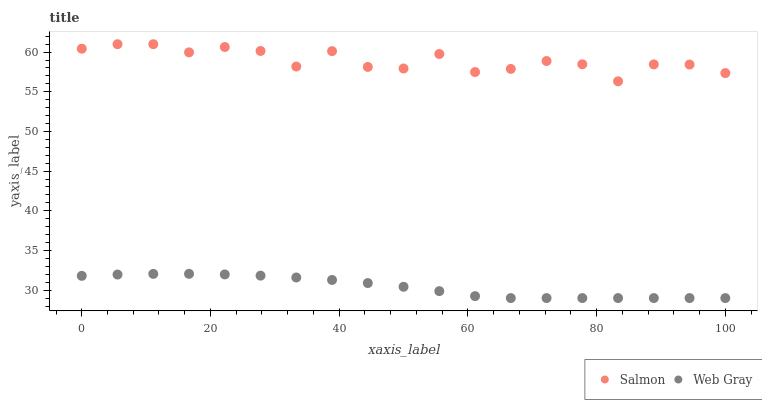Does Web Gray have the minimum area under the curve?
Answer yes or no. Yes. Does Salmon have the maximum area under the curve?
Answer yes or no. Yes. Does Salmon have the minimum area under the curve?
Answer yes or no. No. Is Web Gray the smoothest?
Answer yes or no. Yes. Is Salmon the roughest?
Answer yes or no. Yes. Is Salmon the smoothest?
Answer yes or no. No. Does Web Gray have the lowest value?
Answer yes or no. Yes. Does Salmon have the lowest value?
Answer yes or no. No. Does Salmon have the highest value?
Answer yes or no. Yes. Is Web Gray less than Salmon?
Answer yes or no. Yes. Is Salmon greater than Web Gray?
Answer yes or no. Yes. Does Web Gray intersect Salmon?
Answer yes or no. No. 